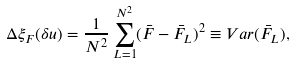<formula> <loc_0><loc_0><loc_500><loc_500>\Delta \xi _ { F } ( \delta u ) = \frac { 1 } { N ^ { 2 } } \sum _ { L = 1 } ^ { N ^ { 2 } } ( \bar { F } - \bar { F } _ { L } ) ^ { 2 } \equiv V a r ( \bar { F } _ { L } ) ,</formula> 